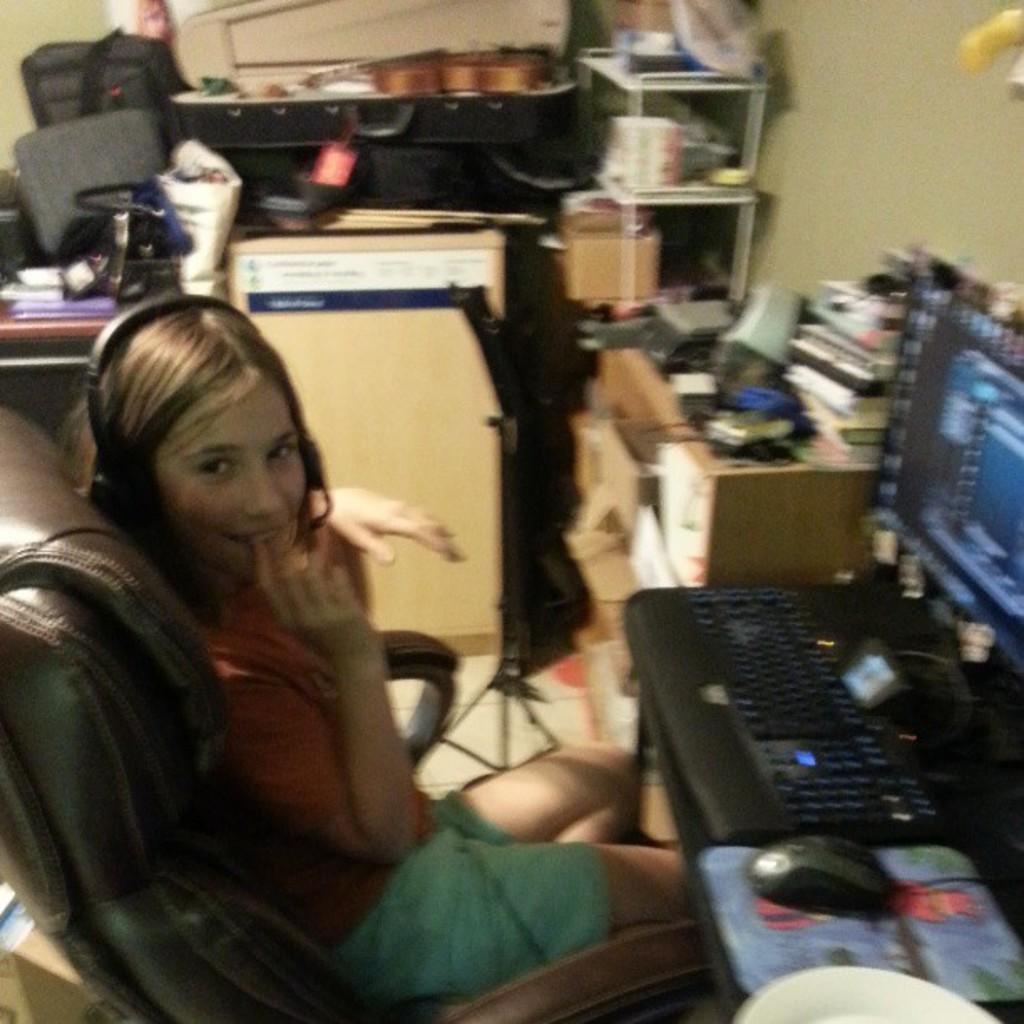Could you give a brief overview of what you see in this image? The person wearing pink shirt is sitting in a chair and wearing a head set and there is a computer in front of her and there are some other stuff beside her. 